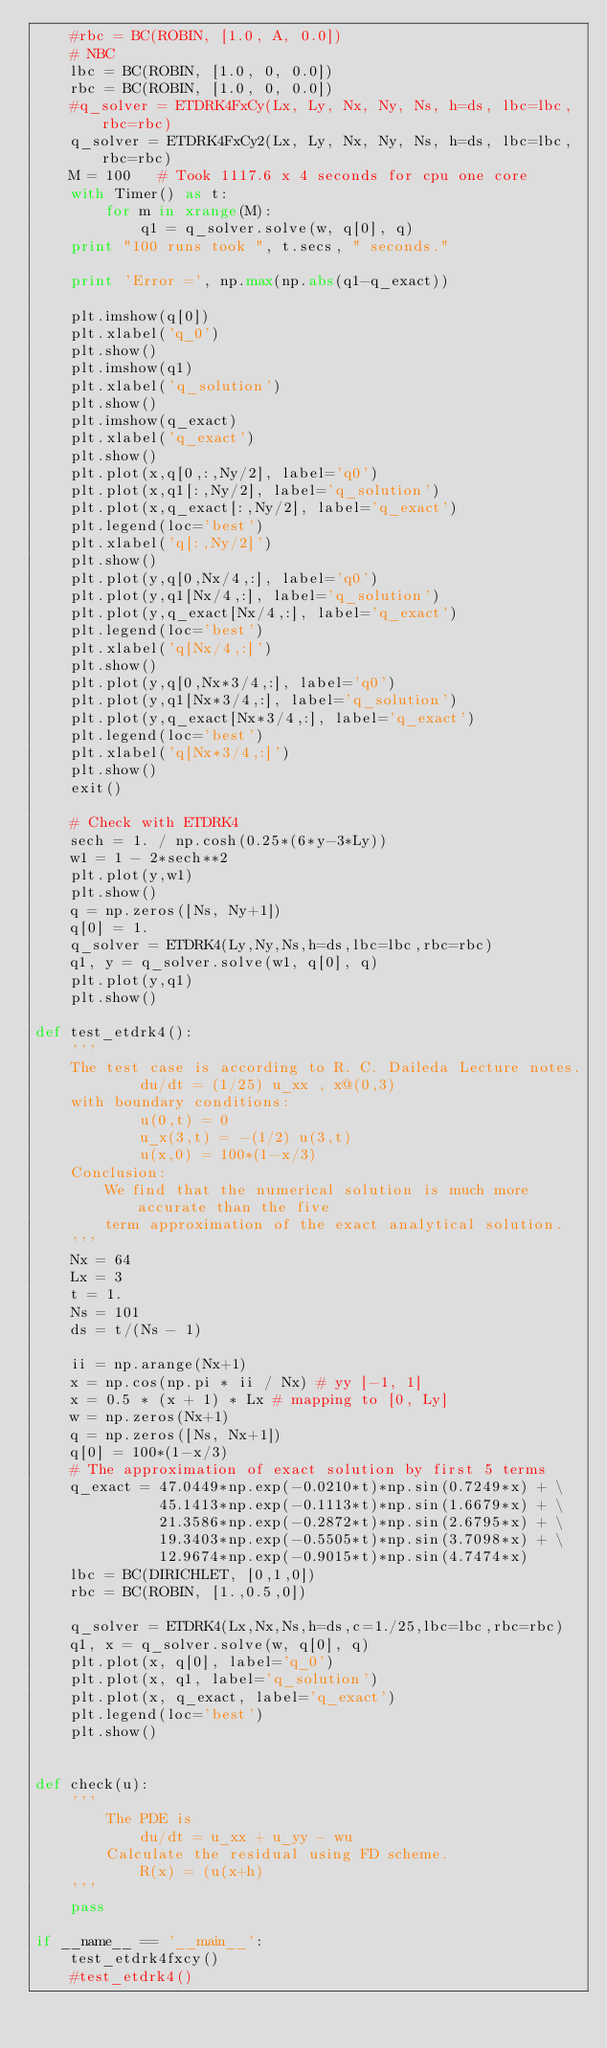<code> <loc_0><loc_0><loc_500><loc_500><_Python_>    #rbc = BC(ROBIN, [1.0, A, 0.0])
    # NBC
    lbc = BC(ROBIN, [1.0, 0, 0.0])
    rbc = BC(ROBIN, [1.0, 0, 0.0])
    #q_solver = ETDRK4FxCy(Lx, Ly, Nx, Ny, Ns, h=ds, lbc=lbc, rbc=rbc)
    q_solver = ETDRK4FxCy2(Lx, Ly, Nx, Ny, Ns, h=ds, lbc=lbc, rbc=rbc)
    M = 100   # Took 1117.6 x 4 seconds for cpu one core
    with Timer() as t:
        for m in xrange(M):
            q1 = q_solver.solve(w, q[0], q)
    print "100 runs took ", t.secs, " seconds."

    print 'Error =', np.max(np.abs(q1-q_exact))

    plt.imshow(q[0])
    plt.xlabel('q_0')
    plt.show()
    plt.imshow(q1)
    plt.xlabel('q_solution')
    plt.show()
    plt.imshow(q_exact)
    plt.xlabel('q_exact')
    plt.show()
    plt.plot(x,q[0,:,Ny/2], label='q0')
    plt.plot(x,q1[:,Ny/2], label='q_solution')
    plt.plot(x,q_exact[:,Ny/2], label='q_exact')
    plt.legend(loc='best')
    plt.xlabel('q[:,Ny/2]')
    plt.show()
    plt.plot(y,q[0,Nx/4,:], label='q0')
    plt.plot(y,q1[Nx/4,:], label='q_solution')
    plt.plot(y,q_exact[Nx/4,:], label='q_exact')
    plt.legend(loc='best')
    plt.xlabel('q[Nx/4,:]')
    plt.show()
    plt.plot(y,q[0,Nx*3/4,:], label='q0')
    plt.plot(y,q1[Nx*3/4,:], label='q_solution')
    plt.plot(y,q_exact[Nx*3/4,:], label='q_exact')
    plt.legend(loc='best')
    plt.xlabel('q[Nx*3/4,:]')
    plt.show()
    exit()

    # Check with ETDRK4
    sech = 1. / np.cosh(0.25*(6*y-3*Ly))
    w1 = 1 - 2*sech**2
    plt.plot(y,w1)
    plt.show()
    q = np.zeros([Ns, Ny+1])
    q[0] = 1.
    q_solver = ETDRK4(Ly,Ny,Ns,h=ds,lbc=lbc,rbc=rbc)
    q1, y = q_solver.solve(w1, q[0], q)
    plt.plot(y,q1)
    plt.show()

def test_etdrk4():
    '''
    The test case is according to R. C. Daileda Lecture notes.
            du/dt = (1/25) u_xx , x@(0,3)
    with boundary conditions:
            u(0,t) = 0
            u_x(3,t) = -(1/2) u(3,t)
            u(x,0) = 100*(1-x/3)
    Conclusion:
        We find that the numerical solution is much more accurate than the five
        term approximation of the exact analytical solution.
    '''
    Nx = 64
    Lx = 3
    t = 1.
    Ns = 101
    ds = t/(Ns - 1)

    ii = np.arange(Nx+1)
    x = np.cos(np.pi * ii / Nx) # yy [-1, 1]
    x = 0.5 * (x + 1) * Lx # mapping to [0, Ly]
    w = np.zeros(Nx+1)
    q = np.zeros([Ns, Nx+1])
    q[0] = 100*(1-x/3)
    # The approximation of exact solution by first 5 terms
    q_exact = 47.0449*np.exp(-0.0210*t)*np.sin(0.7249*x) + \
              45.1413*np.exp(-0.1113*t)*np.sin(1.6679*x) + \
              21.3586*np.exp(-0.2872*t)*np.sin(2.6795*x) + \
              19.3403*np.exp(-0.5505*t)*np.sin(3.7098*x) + \
              12.9674*np.exp(-0.9015*t)*np.sin(4.7474*x)
    lbc = BC(DIRICHLET, [0,1,0])
    rbc = BC(ROBIN, [1.,0.5,0])

    q_solver = ETDRK4(Lx,Nx,Ns,h=ds,c=1./25,lbc=lbc,rbc=rbc)
    q1, x = q_solver.solve(w, q[0], q)
    plt.plot(x, q[0], label='q_0')
    plt.plot(x, q1, label='q_solution')
    plt.plot(x, q_exact, label='q_exact')
    plt.legend(loc='best')
    plt.show()


def check(u):
    '''
        The PDE is
            du/dt = u_xx + u_yy - wu
        Calculate the residual using FD scheme.
            R(x) = (u(x+h)
    '''
    pass

if __name__ == '__main__':
    test_etdrk4fxcy()
    #test_etdrk4()

</code> 